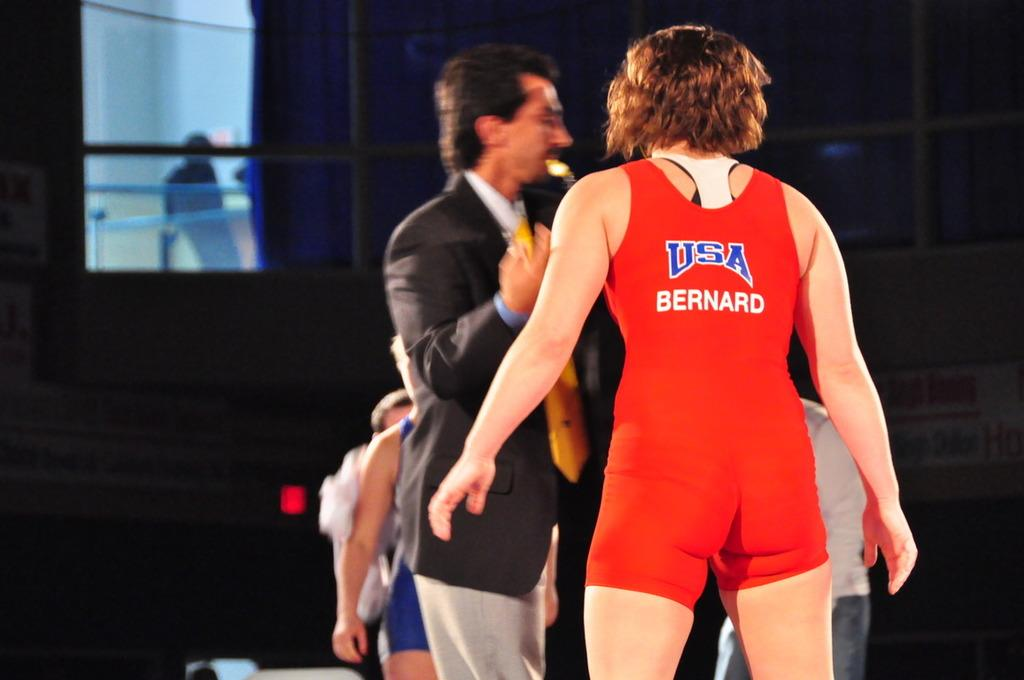How many people are present in the image? There are four persons in the image. Can you describe the attire of one of the persons? One person is wearing a suit. What can be said about the background of the image? The background of the image is darker. What type of plastic bear can be seen in the image? There is no plastic bear present in the image. How many bears are visible in the image? There are no bears visible in the image. 